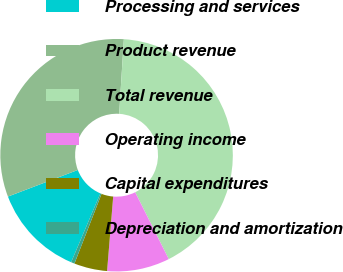Convert chart to OTSL. <chart><loc_0><loc_0><loc_500><loc_500><pie_chart><fcel>Processing and services<fcel>Product revenue<fcel>Total revenue<fcel>Operating income<fcel>Capital expenditures<fcel>Depreciation and amortization<nl><fcel>12.82%<fcel>31.79%<fcel>41.6%<fcel>8.71%<fcel>4.6%<fcel>0.49%<nl></chart> 